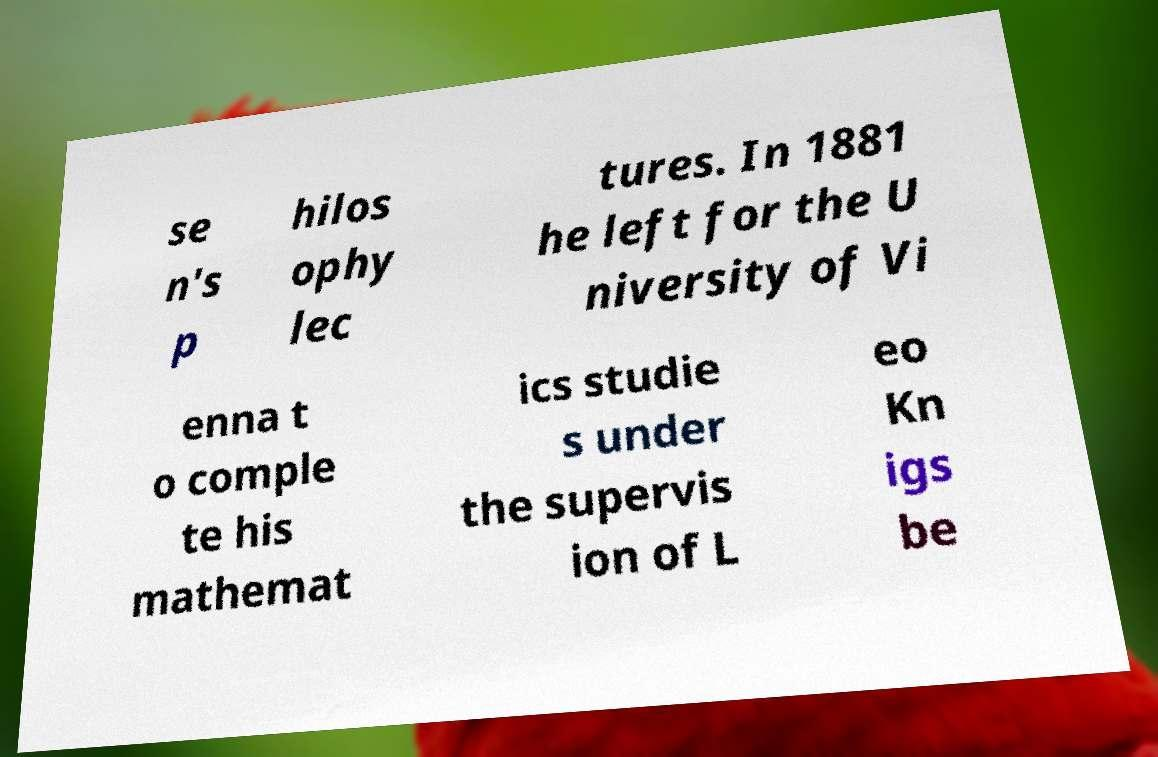There's text embedded in this image that I need extracted. Can you transcribe it verbatim? se n's p hilos ophy lec tures. In 1881 he left for the U niversity of Vi enna t o comple te his mathemat ics studie s under the supervis ion of L eo Kn igs be 